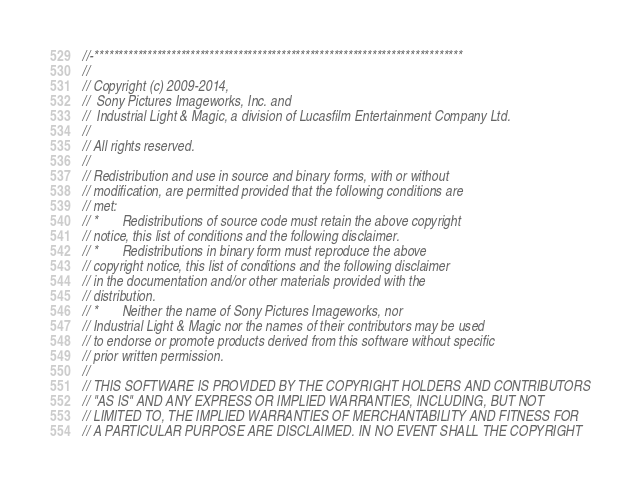Convert code to text. <code><loc_0><loc_0><loc_500><loc_500><_C++_>//-*****************************************************************************
//
// Copyright (c) 2009-2014,
//  Sony Pictures Imageworks, Inc. and
//  Industrial Light & Magic, a division of Lucasfilm Entertainment Company Ltd.
//
// All rights reserved.
//
// Redistribution and use in source and binary forms, with or without
// modification, are permitted provided that the following conditions are
// met:
// *       Redistributions of source code must retain the above copyright
// notice, this list of conditions and the following disclaimer.
// *       Redistributions in binary form must reproduce the above
// copyright notice, this list of conditions and the following disclaimer
// in the documentation and/or other materials provided with the
// distribution.
// *       Neither the name of Sony Pictures Imageworks, nor
// Industrial Light & Magic nor the names of their contributors may be used
// to endorse or promote products derived from this software without specific
// prior written permission.
//
// THIS SOFTWARE IS PROVIDED BY THE COPYRIGHT HOLDERS AND CONTRIBUTORS
// "AS IS" AND ANY EXPRESS OR IMPLIED WARRANTIES, INCLUDING, BUT NOT
// LIMITED TO, THE IMPLIED WARRANTIES OF MERCHANTABILITY AND FITNESS FOR
// A PARTICULAR PURPOSE ARE DISCLAIMED. IN NO EVENT SHALL THE COPYRIGHT</code> 